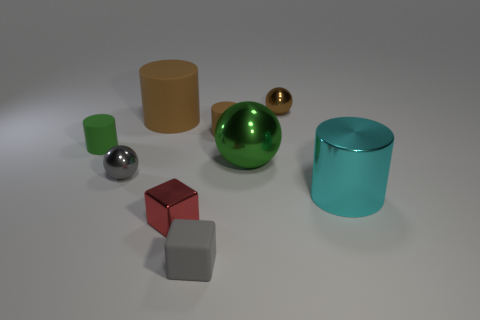Add 1 metal cubes. How many objects exist? 10 Subtract all cylinders. How many objects are left? 5 Subtract all large gray metal blocks. Subtract all green matte cylinders. How many objects are left? 8 Add 6 red objects. How many red objects are left? 7 Add 6 green metal things. How many green metal things exist? 7 Subtract 0 yellow spheres. How many objects are left? 9 